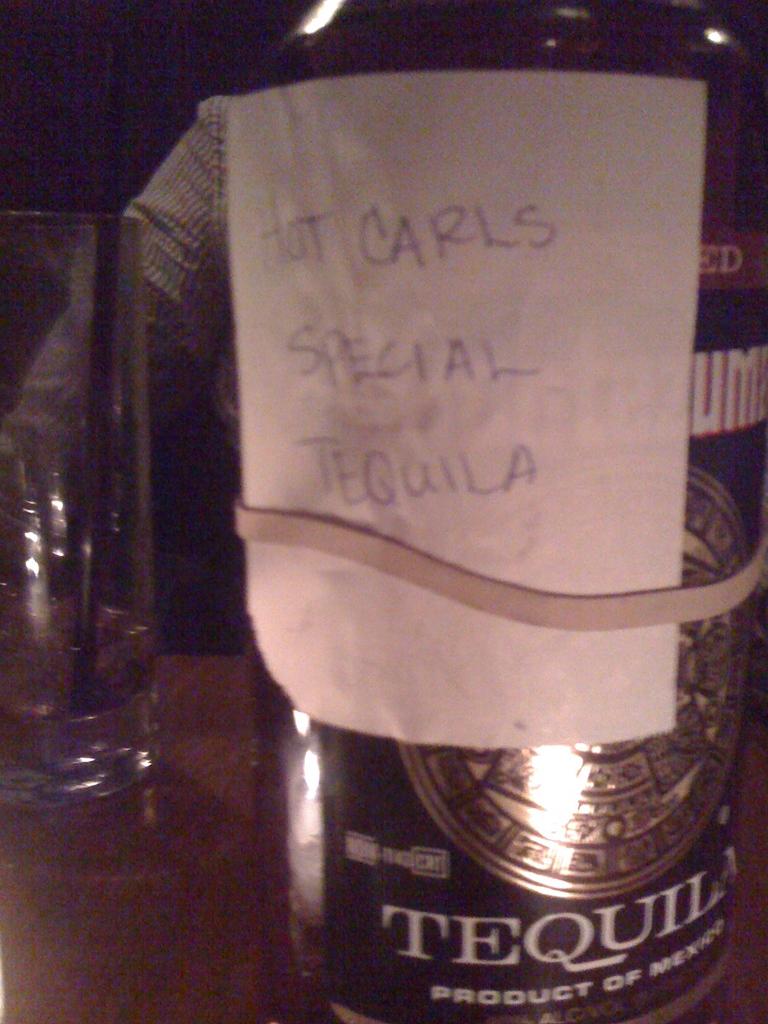Whose special tequila is this?
Your response must be concise. Hot carls. 